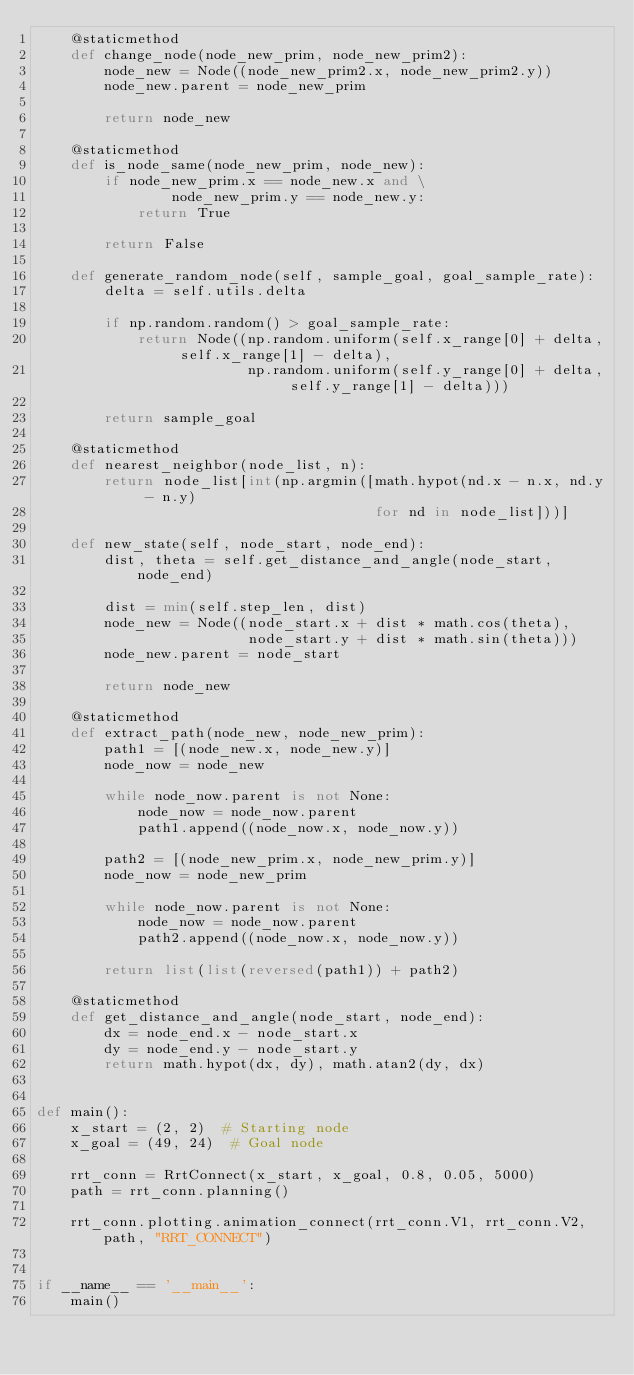Convert code to text. <code><loc_0><loc_0><loc_500><loc_500><_Python_>    @staticmethod
    def change_node(node_new_prim, node_new_prim2):
        node_new = Node((node_new_prim2.x, node_new_prim2.y))
        node_new.parent = node_new_prim

        return node_new

    @staticmethod
    def is_node_same(node_new_prim, node_new):
        if node_new_prim.x == node_new.x and \
                node_new_prim.y == node_new.y:
            return True

        return False

    def generate_random_node(self, sample_goal, goal_sample_rate):
        delta = self.utils.delta

        if np.random.random() > goal_sample_rate:
            return Node((np.random.uniform(self.x_range[0] + delta, self.x_range[1] - delta),
                         np.random.uniform(self.y_range[0] + delta, self.y_range[1] - delta)))

        return sample_goal

    @staticmethod
    def nearest_neighbor(node_list, n):
        return node_list[int(np.argmin([math.hypot(nd.x - n.x, nd.y - n.y)
                                        for nd in node_list]))]

    def new_state(self, node_start, node_end):
        dist, theta = self.get_distance_and_angle(node_start, node_end)

        dist = min(self.step_len, dist)
        node_new = Node((node_start.x + dist * math.cos(theta),
                         node_start.y + dist * math.sin(theta)))
        node_new.parent = node_start

        return node_new

    @staticmethod
    def extract_path(node_new, node_new_prim):
        path1 = [(node_new.x, node_new.y)]
        node_now = node_new

        while node_now.parent is not None:
            node_now = node_now.parent
            path1.append((node_now.x, node_now.y))

        path2 = [(node_new_prim.x, node_new_prim.y)]
        node_now = node_new_prim

        while node_now.parent is not None:
            node_now = node_now.parent
            path2.append((node_now.x, node_now.y))

        return list(list(reversed(path1)) + path2)

    @staticmethod
    def get_distance_and_angle(node_start, node_end):
        dx = node_end.x - node_start.x
        dy = node_end.y - node_start.y
        return math.hypot(dx, dy), math.atan2(dy, dx)


def main():
    x_start = (2, 2)  # Starting node
    x_goal = (49, 24)  # Goal node

    rrt_conn = RrtConnect(x_start, x_goal, 0.8, 0.05, 5000)
    path = rrt_conn.planning()

    rrt_conn.plotting.animation_connect(rrt_conn.V1, rrt_conn.V2, path, "RRT_CONNECT")


if __name__ == '__main__':
    main()
</code> 